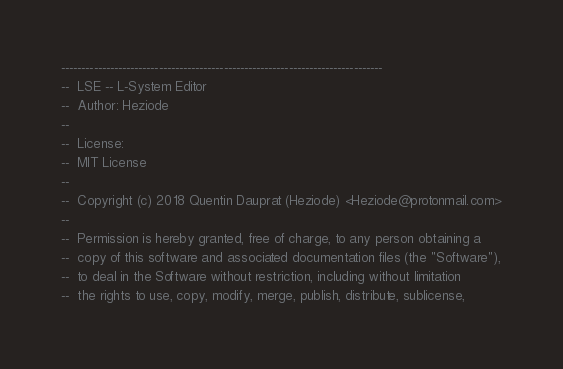<code> <loc_0><loc_0><loc_500><loc_500><_Ada_>-------------------------------------------------------------------------------
--  LSE -- L-System Editor
--  Author: Heziode
--
--  License:
--  MIT License
--
--  Copyright (c) 2018 Quentin Dauprat (Heziode) <Heziode@protonmail.com>
--
--  Permission is hereby granted, free of charge, to any person obtaining a
--  copy of this software and associated documentation files (the "Software"),
--  to deal in the Software without restriction, including without limitation
--  the rights to use, copy, modify, merge, publish, distribute, sublicense,</code> 